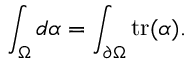Convert formula to latex. <formula><loc_0><loc_0><loc_500><loc_500>\int _ { \Omega } d \alpha = \int _ { \partial \Omega } t r ( \alpha ) .</formula> 